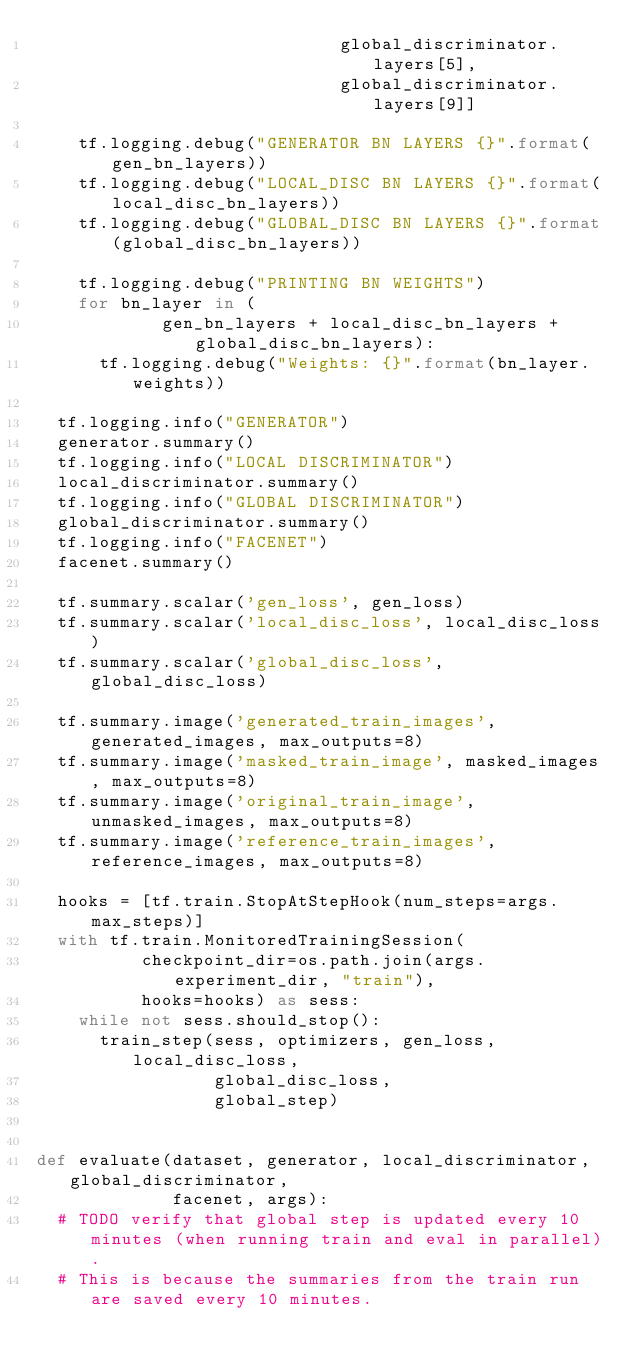Convert code to text. <code><loc_0><loc_0><loc_500><loc_500><_Python_>                             global_discriminator.layers[5],
                             global_discriminator.layers[9]]

    tf.logging.debug("GENERATOR BN LAYERS {}".format(gen_bn_layers))
    tf.logging.debug("LOCAL_DISC BN LAYERS {}".format(local_disc_bn_layers))
    tf.logging.debug("GLOBAL_DISC BN LAYERS {}".format(global_disc_bn_layers))

    tf.logging.debug("PRINTING BN WEIGHTS")
    for bn_layer in (
            gen_bn_layers + local_disc_bn_layers + global_disc_bn_layers):
      tf.logging.debug("Weights: {}".format(bn_layer.weights))

  tf.logging.info("GENERATOR")
  generator.summary()
  tf.logging.info("LOCAL DISCRIMINATOR")
  local_discriminator.summary()
  tf.logging.info("GLOBAL DISCRIMINATOR")
  global_discriminator.summary()
  tf.logging.info("FACENET")
  facenet.summary()

  tf.summary.scalar('gen_loss', gen_loss)
  tf.summary.scalar('local_disc_loss', local_disc_loss)
  tf.summary.scalar('global_disc_loss', global_disc_loss)

  tf.summary.image('generated_train_images', generated_images, max_outputs=8)
  tf.summary.image('masked_train_image', masked_images, max_outputs=8)
  tf.summary.image('original_train_image', unmasked_images, max_outputs=8)
  tf.summary.image('reference_train_images', reference_images, max_outputs=8)

  hooks = [tf.train.StopAtStepHook(num_steps=args.max_steps)]
  with tf.train.MonitoredTrainingSession(
          checkpoint_dir=os.path.join(args.experiment_dir, "train"),
          hooks=hooks) as sess:
    while not sess.should_stop():
      train_step(sess, optimizers, gen_loss, local_disc_loss,
                 global_disc_loss,
                 global_step)


def evaluate(dataset, generator, local_discriminator, global_discriminator,
             facenet, args):
  # TODO verify that global step is updated every 10 minutes (when running train and eval in parallel).
  # This is because the summaries from the train run are saved every 10 minutes.</code> 